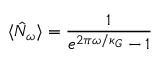Convert formula to latex. <formula><loc_0><loc_0><loc_500><loc_500>\langle \hat { N } _ { \omega } \rangle = \frac { 1 } { e ^ { 2 \pi \omega / \kappa _ { G } } - 1 }</formula> 